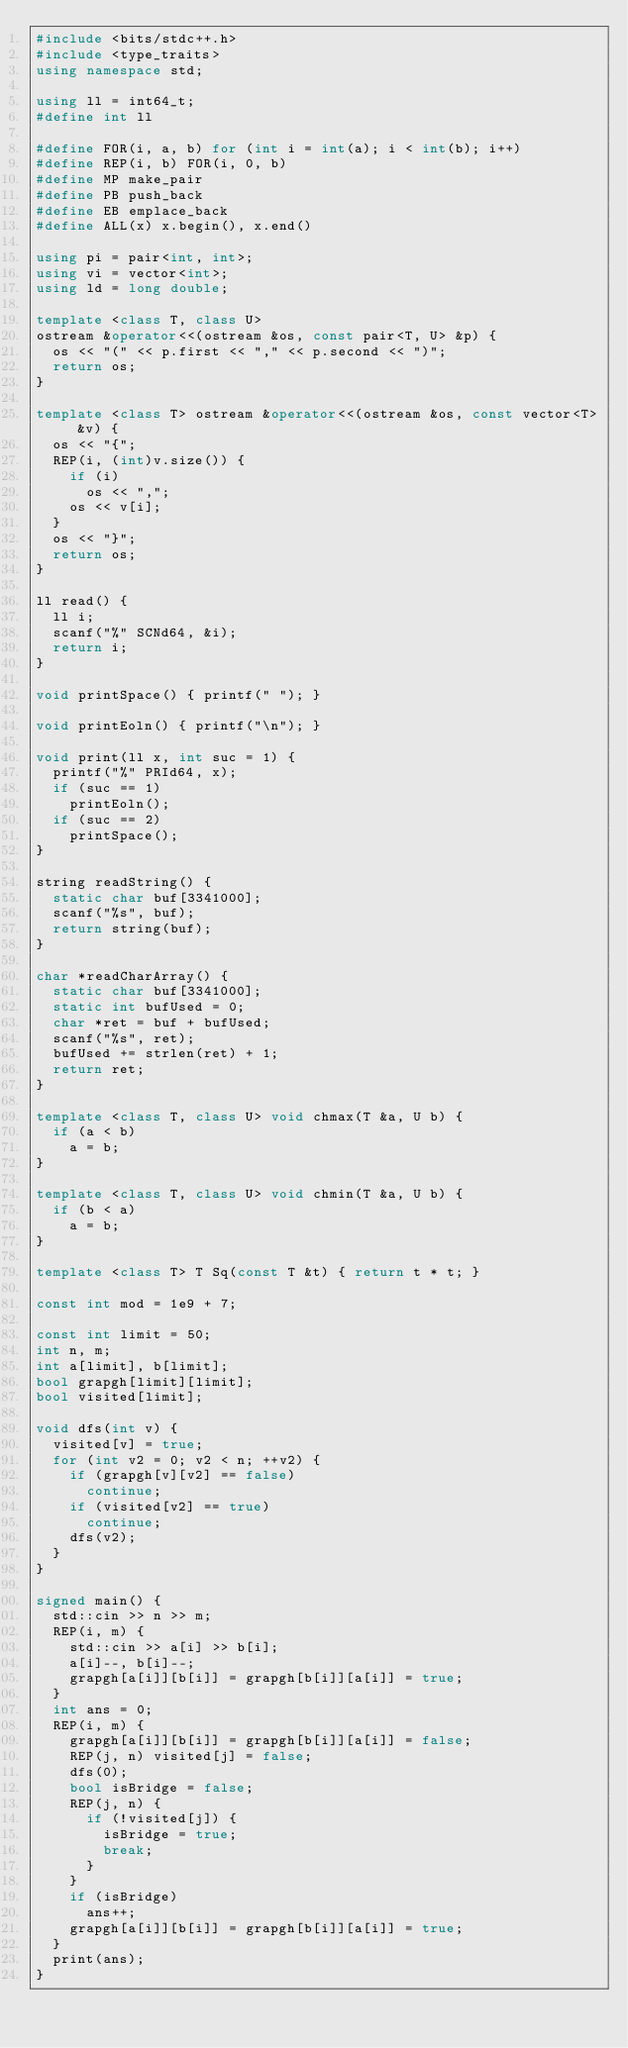Convert code to text. <code><loc_0><loc_0><loc_500><loc_500><_C++_>#include <bits/stdc++.h>
#include <type_traits>
using namespace std;

using ll = int64_t;
#define int ll

#define FOR(i, a, b) for (int i = int(a); i < int(b); i++)
#define REP(i, b) FOR(i, 0, b)
#define MP make_pair
#define PB push_back
#define EB emplace_back
#define ALL(x) x.begin(), x.end()

using pi = pair<int, int>;
using vi = vector<int>;
using ld = long double;

template <class T, class U>
ostream &operator<<(ostream &os, const pair<T, U> &p) {
  os << "(" << p.first << "," << p.second << ")";
  return os;
}

template <class T> ostream &operator<<(ostream &os, const vector<T> &v) {
  os << "{";
  REP(i, (int)v.size()) {
    if (i)
      os << ",";
    os << v[i];
  }
  os << "}";
  return os;
}

ll read() {
  ll i;
  scanf("%" SCNd64, &i);
  return i;
}

void printSpace() { printf(" "); }

void printEoln() { printf("\n"); }

void print(ll x, int suc = 1) {
  printf("%" PRId64, x);
  if (suc == 1)
    printEoln();
  if (suc == 2)
    printSpace();
}

string readString() {
  static char buf[3341000];
  scanf("%s", buf);
  return string(buf);
}

char *readCharArray() {
  static char buf[3341000];
  static int bufUsed = 0;
  char *ret = buf + bufUsed;
  scanf("%s", ret);
  bufUsed += strlen(ret) + 1;
  return ret;
}

template <class T, class U> void chmax(T &a, U b) {
  if (a < b)
    a = b;
}

template <class T, class U> void chmin(T &a, U b) {
  if (b < a)
    a = b;
}

template <class T> T Sq(const T &t) { return t * t; }

const int mod = 1e9 + 7;

const int limit = 50;
int n, m;
int a[limit], b[limit];
bool grapgh[limit][limit];
bool visited[limit];

void dfs(int v) {
  visited[v] = true;
  for (int v2 = 0; v2 < n; ++v2) {
    if (grapgh[v][v2] == false)
      continue;
    if (visited[v2] == true)
      continue;
    dfs(v2);
  }
}

signed main() {
  std::cin >> n >> m;
  REP(i, m) {
    std::cin >> a[i] >> b[i];
    a[i]--, b[i]--;
    grapgh[a[i]][b[i]] = grapgh[b[i]][a[i]] = true;
  }
  int ans = 0;
  REP(i, m) {
    grapgh[a[i]][b[i]] = grapgh[b[i]][a[i]] = false;
    REP(j, n) visited[j] = false;
    dfs(0);
    bool isBridge = false;
    REP(j, n) {
      if (!visited[j]) {
        isBridge = true;
        break;
      }
    }
    if (isBridge)
      ans++;
    grapgh[a[i]][b[i]] = grapgh[b[i]][a[i]] = true;
  }
  print(ans);
}
</code> 